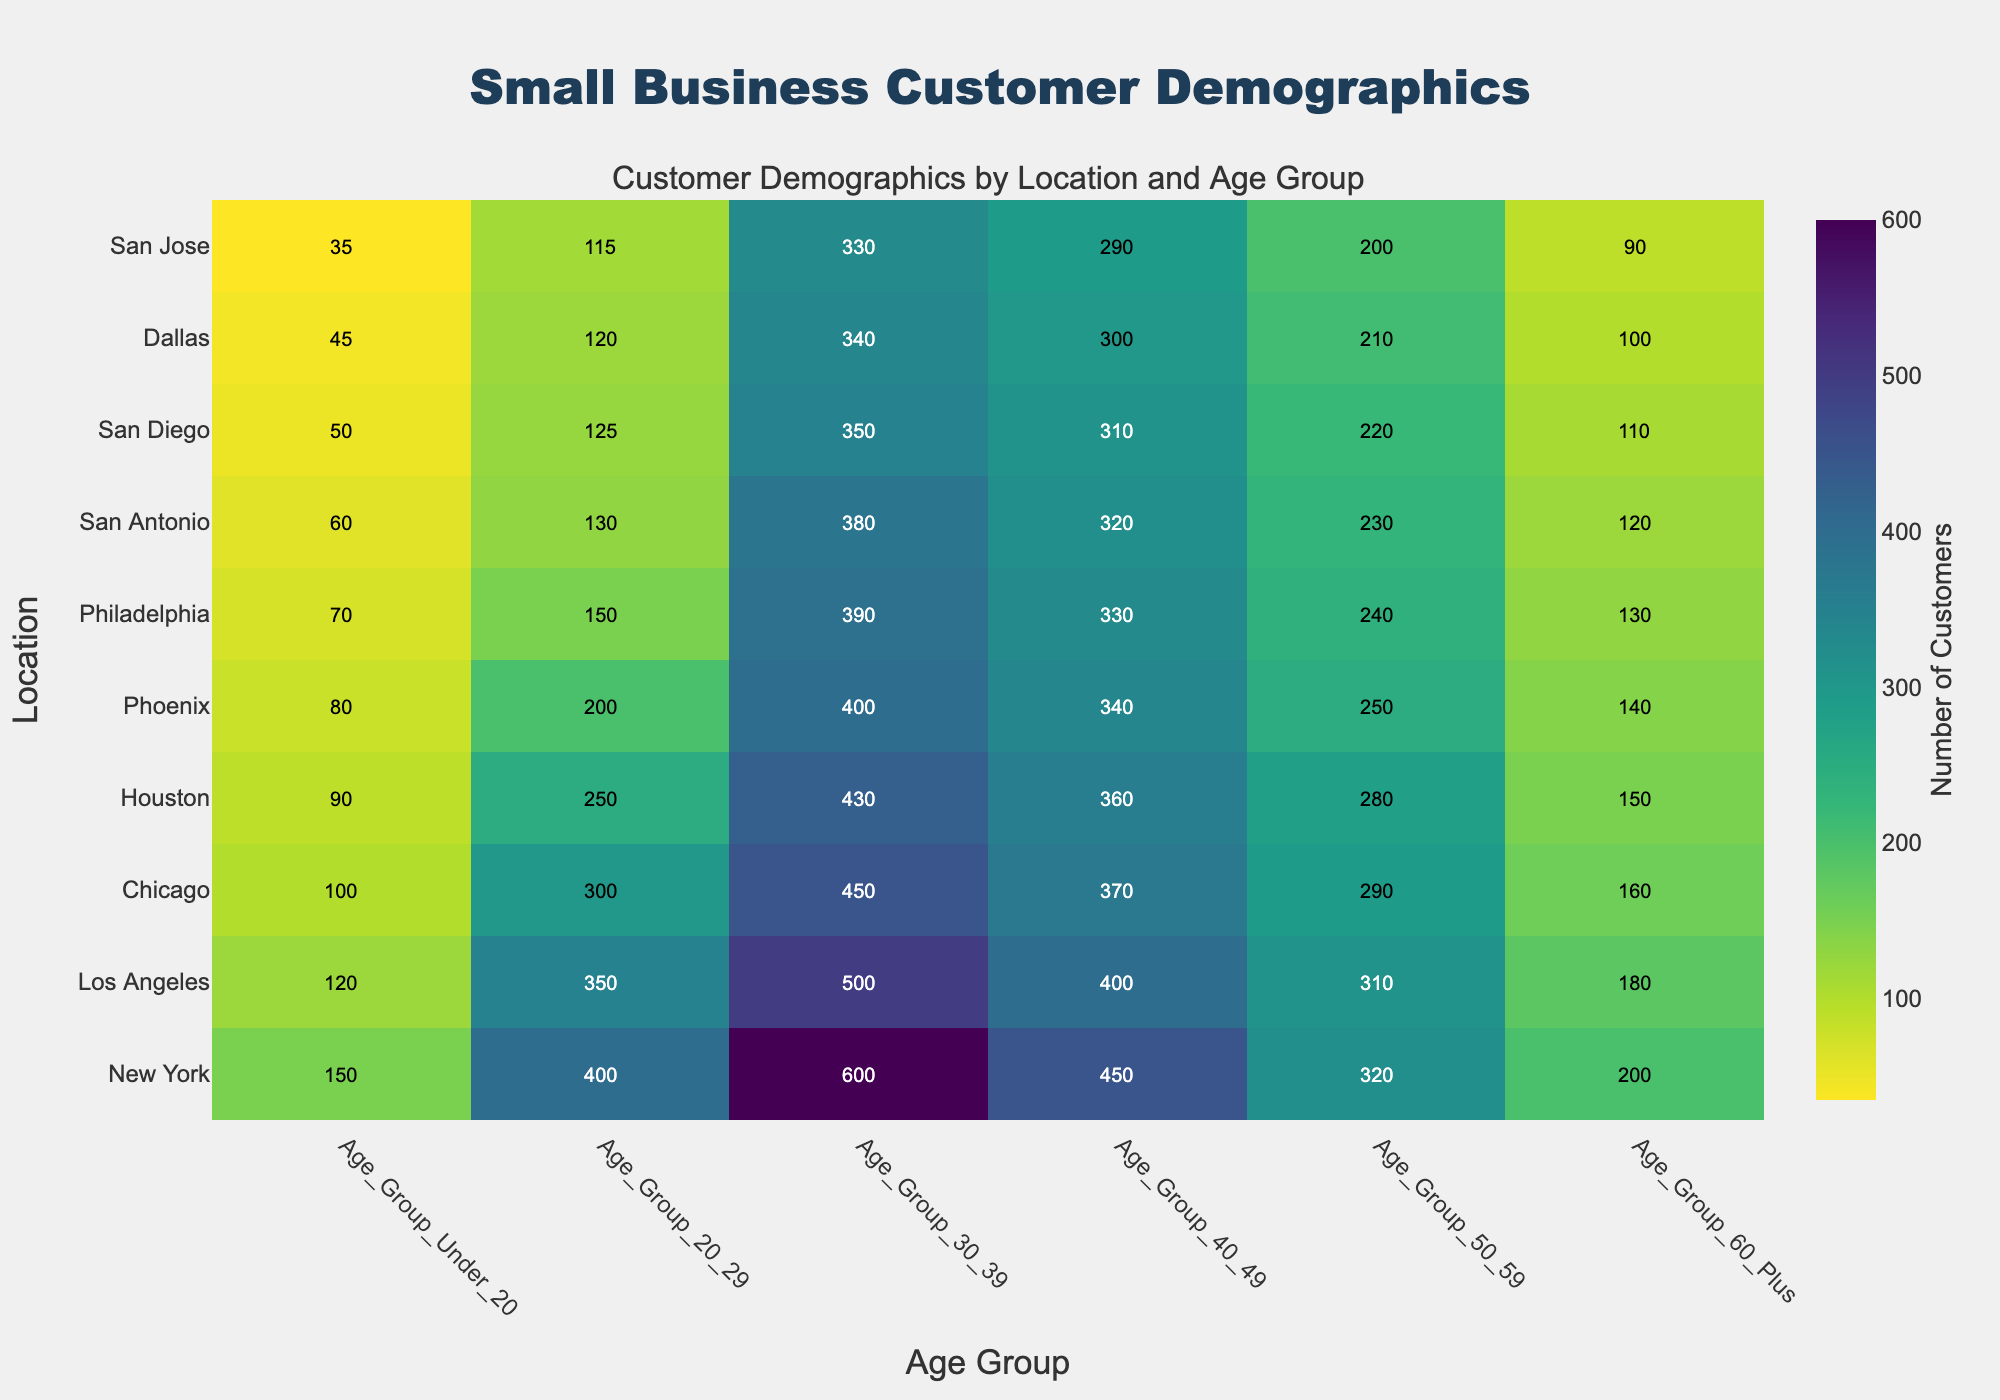How many age groups are displayed in the chart? Count the number of distinct age groups listed on the x-axis of the heatmap.
Answer: 6 Which location has the highest number of customers in the age group 30-39? Identify the location by checking the values under the age group 30-39 and find the maximum number.
Answer: New York What is the total number of customers in Chicago across all age groups? Add the numbers corresponding to Chicago across all the age groups, i.e., 100 + 300 + 450 + 370 + 290 + 160.
Answer: 1670 Which age group has the least number of customers in Houston? Look at all the values for Houston across the different age groups and find the smallest one.
Answer: Under 20 How does the number of customers in the 60+ age group in Dallas compare to the same age group in Phoenix? Compare the values for the 60+ age group in Dallas and Phoenix. Dallas has 100, and Phoenix has 140, so Dallas has fewer.
Answer: Phoenix has more Which city has the most uniform distribution of customers across all age groups, and how did you determine this? Visualize the spread of values for each location and check for the least variation. San Antonio, for example, has values that appear more consistent across age groups.
Answer: San Antonio What is the difference in the number of customers between age groups 20-29 and 40-49 in Los Angeles? Subtract the number of customers in the 40-49 age group from the 20-29 age group in Los Angeles. 350 - 400 = -50.
Answer: -50 Can you identify any patterns in customer demographics by location? For example, which locations have high numbers in specific age groups? Identify noticeable trends such as New York and Los Angeles having consistently high numbers in most age groups, especially 30-39 and 40-49.
Answer: New York and Los Angeles have high numbers in most age groups How does the number of customers aged 50-59 in Philadelphia compare to New York? Compare the values in the 50-59 age group for Philadelphia and New York. Philadelphia has 240 customers and New York has 320, so Philadelphia has fewer.
Answer: New York has more Which age group shows the most significant decline in customers from New York to San Jose? Identify the age group by looking at the decrease in values from New York to San Jose across all age groups. The 30-39 age group shows a decrease from 600 to 330.
Answer: 30-39 